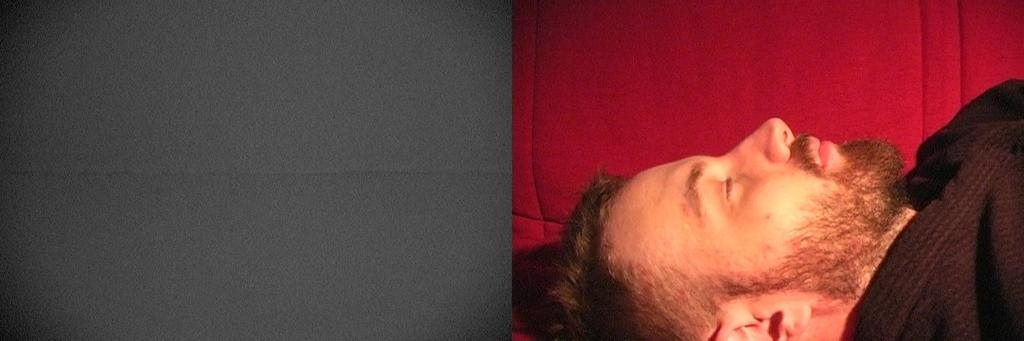What is the main subject of the image? There is a person in the image. What is the person doing in the image? The person is sleeping. On which side of the image is the person located? The person is on the right side of the image. What type of pancake is being served on the left side of the image? There is no pancake present in the image, as the main subject is a person who is sleeping. 